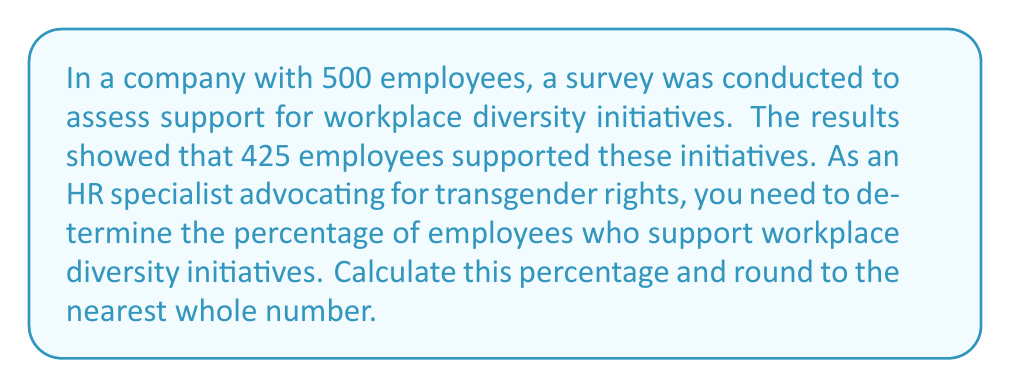Show me your answer to this math problem. To calculate the percentage of employees who support workplace diversity initiatives, we'll follow these steps:

1) First, identify the given information:
   - Total number of employees: 500
   - Number of employees supporting diversity initiatives: 425

2) The formula to calculate percentage is:
   $$ \text{Percentage} = \frac{\text{Part}}{\text{Whole}} \times 100\% $$

3) In this case:
   - Part = Number of employees supporting diversity initiatives = 425
   - Whole = Total number of employees = 500

4) Plug these values into the formula:
   $$ \text{Percentage} = \frac{425}{500} \times 100\% $$

5) Perform the division:
   $$ \text{Percentage} = 0.85 \times 100\% = 85\% $$

6) The question asks to round to the nearest whole number. 85% is already a whole number, so no further rounding is necessary.

Therefore, 85% of employees support workplace diversity initiatives.
Answer: 85% 